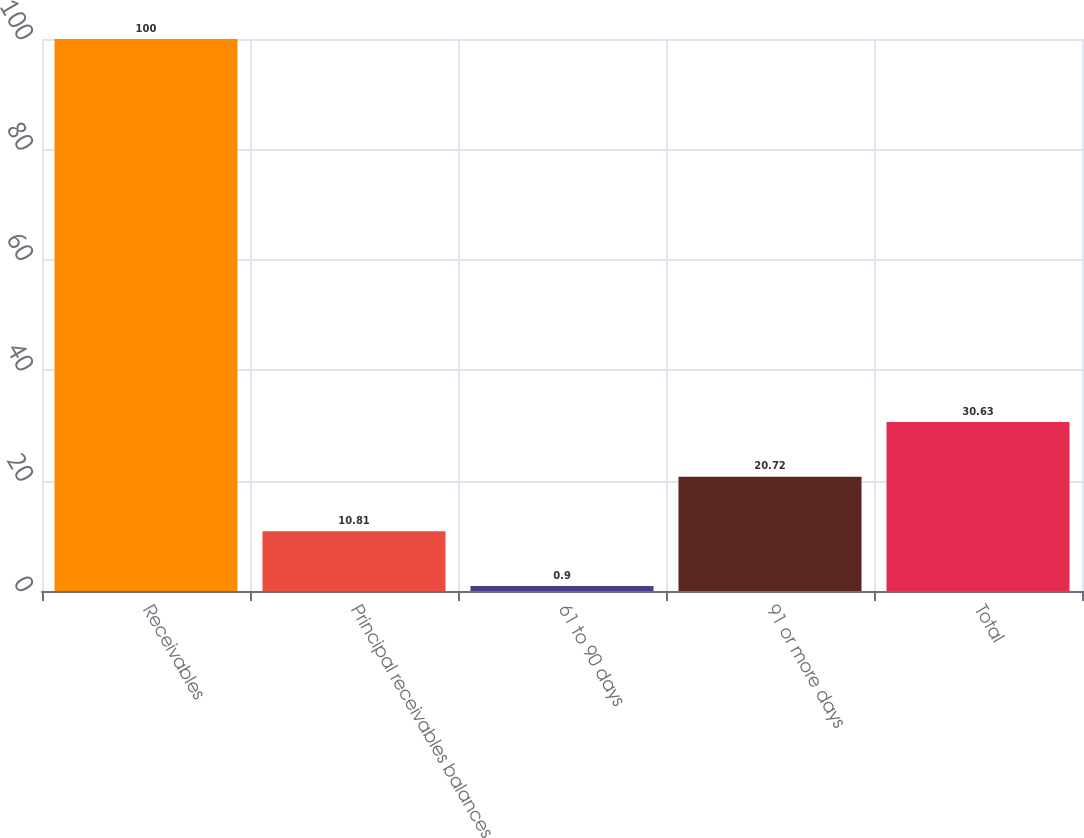Convert chart to OTSL. <chart><loc_0><loc_0><loc_500><loc_500><bar_chart><fcel>Receivables<fcel>Principal receivables balances<fcel>61 to 90 days<fcel>91 or more days<fcel>Total<nl><fcel>100<fcel>10.81<fcel>0.9<fcel>20.72<fcel>30.63<nl></chart> 